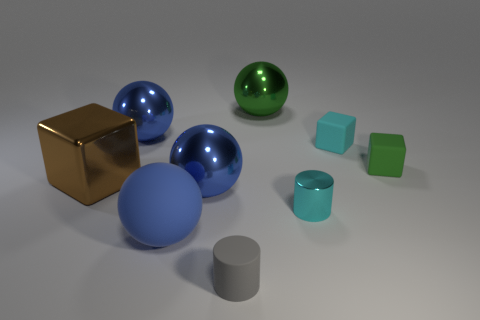How many objects are large blue metallic objects that are on the right side of the large matte thing or gray matte cylinders? There are two large blue metallic objects on the right side of the large matte cube. Additionally, there are two gray matte cylinders present in the image. 